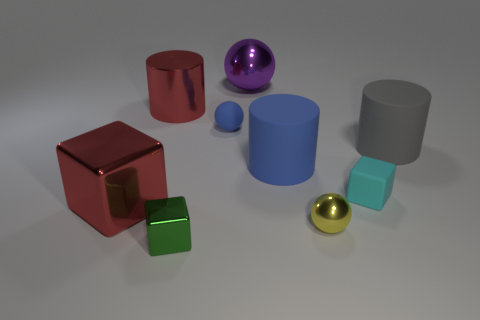Add 1 small spheres. How many objects exist? 10 Subtract all cylinders. How many objects are left? 6 Add 7 cyan blocks. How many cyan blocks are left? 8 Add 8 yellow blocks. How many yellow blocks exist? 8 Subtract 1 red cylinders. How many objects are left? 8 Subtract all small blue balls. Subtract all cyan rubber cubes. How many objects are left? 7 